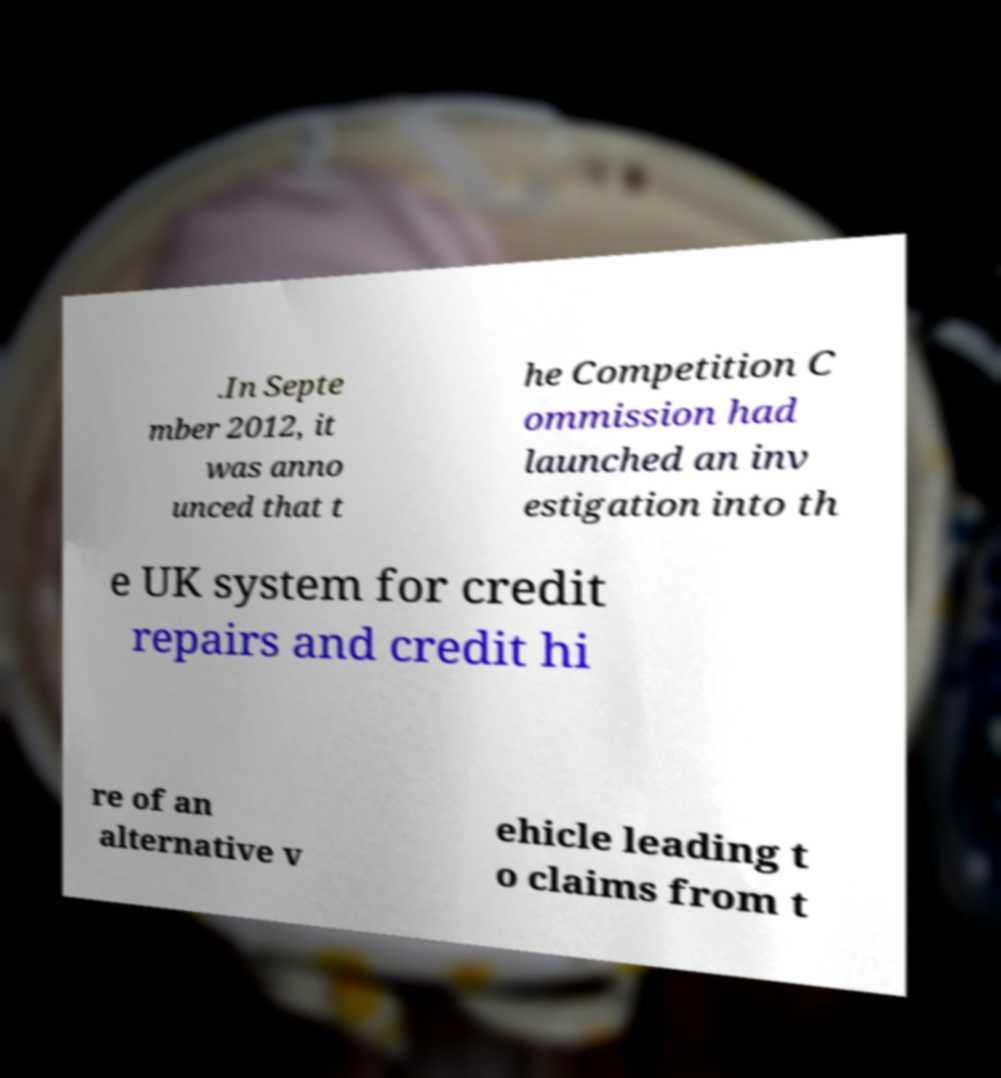For documentation purposes, I need the text within this image transcribed. Could you provide that? .In Septe mber 2012, it was anno unced that t he Competition C ommission had launched an inv estigation into th e UK system for credit repairs and credit hi re of an alternative v ehicle leading t o claims from t 